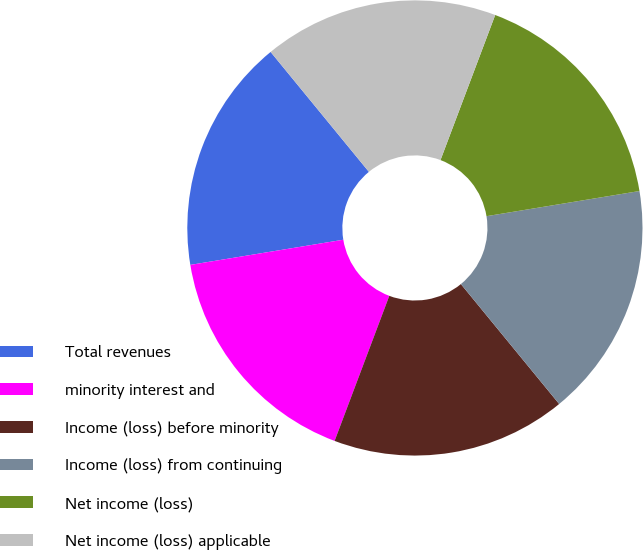<chart> <loc_0><loc_0><loc_500><loc_500><pie_chart><fcel>Total revenues<fcel>minority interest and<fcel>Income (loss) before minority<fcel>Income (loss) from continuing<fcel>Net income (loss)<fcel>Net income (loss) applicable<nl><fcel>16.67%<fcel>16.67%<fcel>16.67%<fcel>16.67%<fcel>16.67%<fcel>16.67%<nl></chart> 